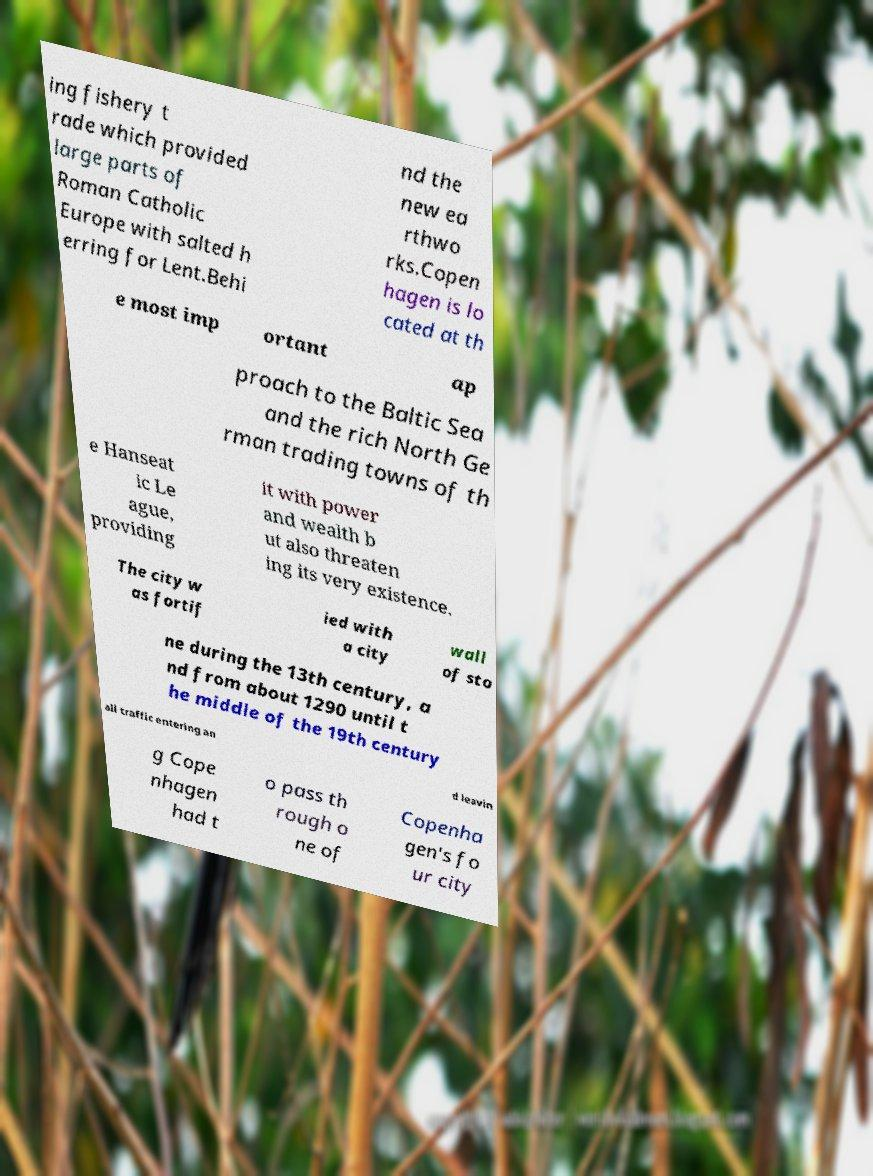Can you read and provide the text displayed in the image?This photo seems to have some interesting text. Can you extract and type it out for me? ing fishery t rade which provided large parts of Roman Catholic Europe with salted h erring for Lent.Behi nd the new ea rthwo rks.Copen hagen is lo cated at th e most imp ortant ap proach to the Baltic Sea and the rich North Ge rman trading towns of th e Hanseat ic Le ague, providing it with power and wealth b ut also threaten ing its very existence. The city w as fortif ied with a city wall of sto ne during the 13th century, a nd from about 1290 until t he middle of the 19th century all traffic entering an d leavin g Cope nhagen had t o pass th rough o ne of Copenha gen's fo ur city 